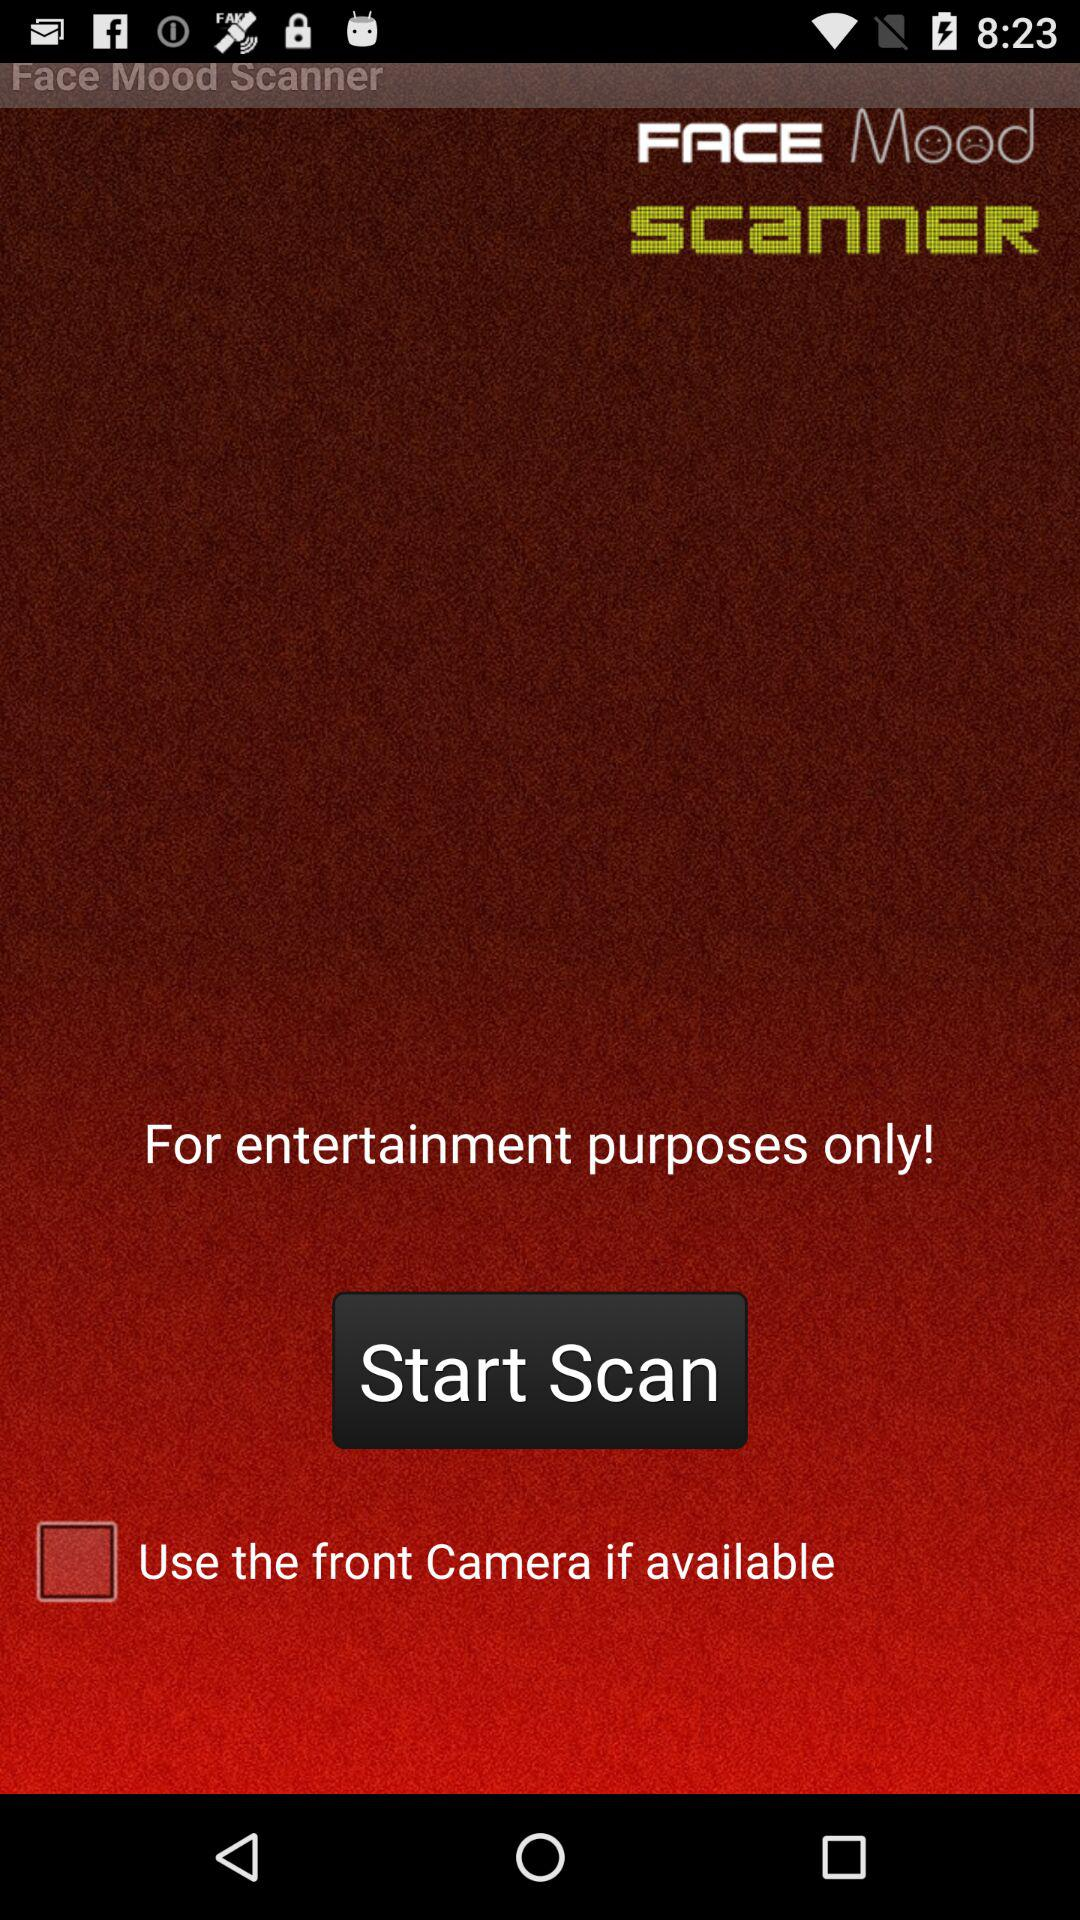What is the status of the "Use the front Camera if available"? The status is off. 